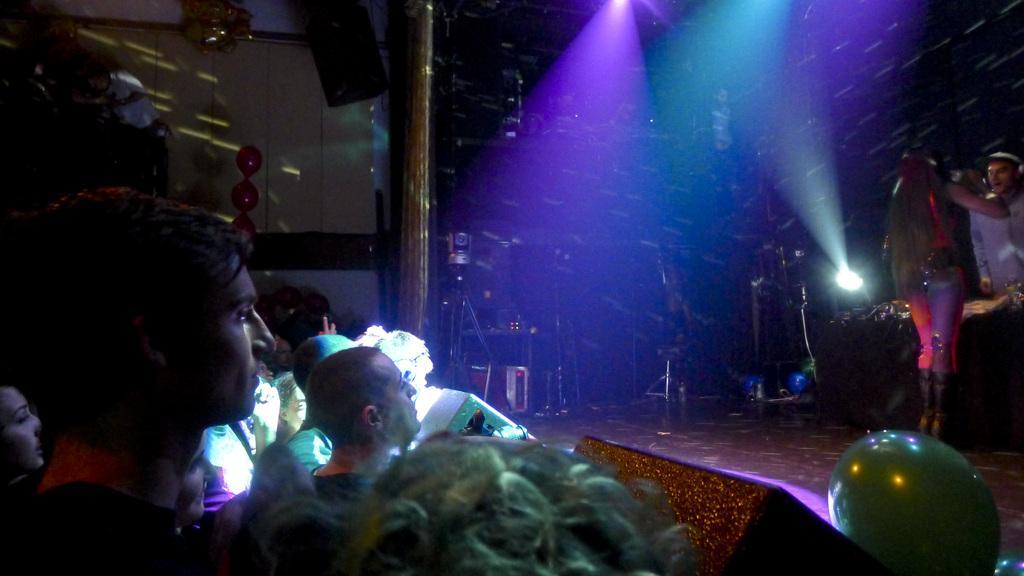Please provide a concise description of this image. This picture shows few people watching and we see couple of them performing on the dais and we see lights and few balloons and a speaker hanging. 